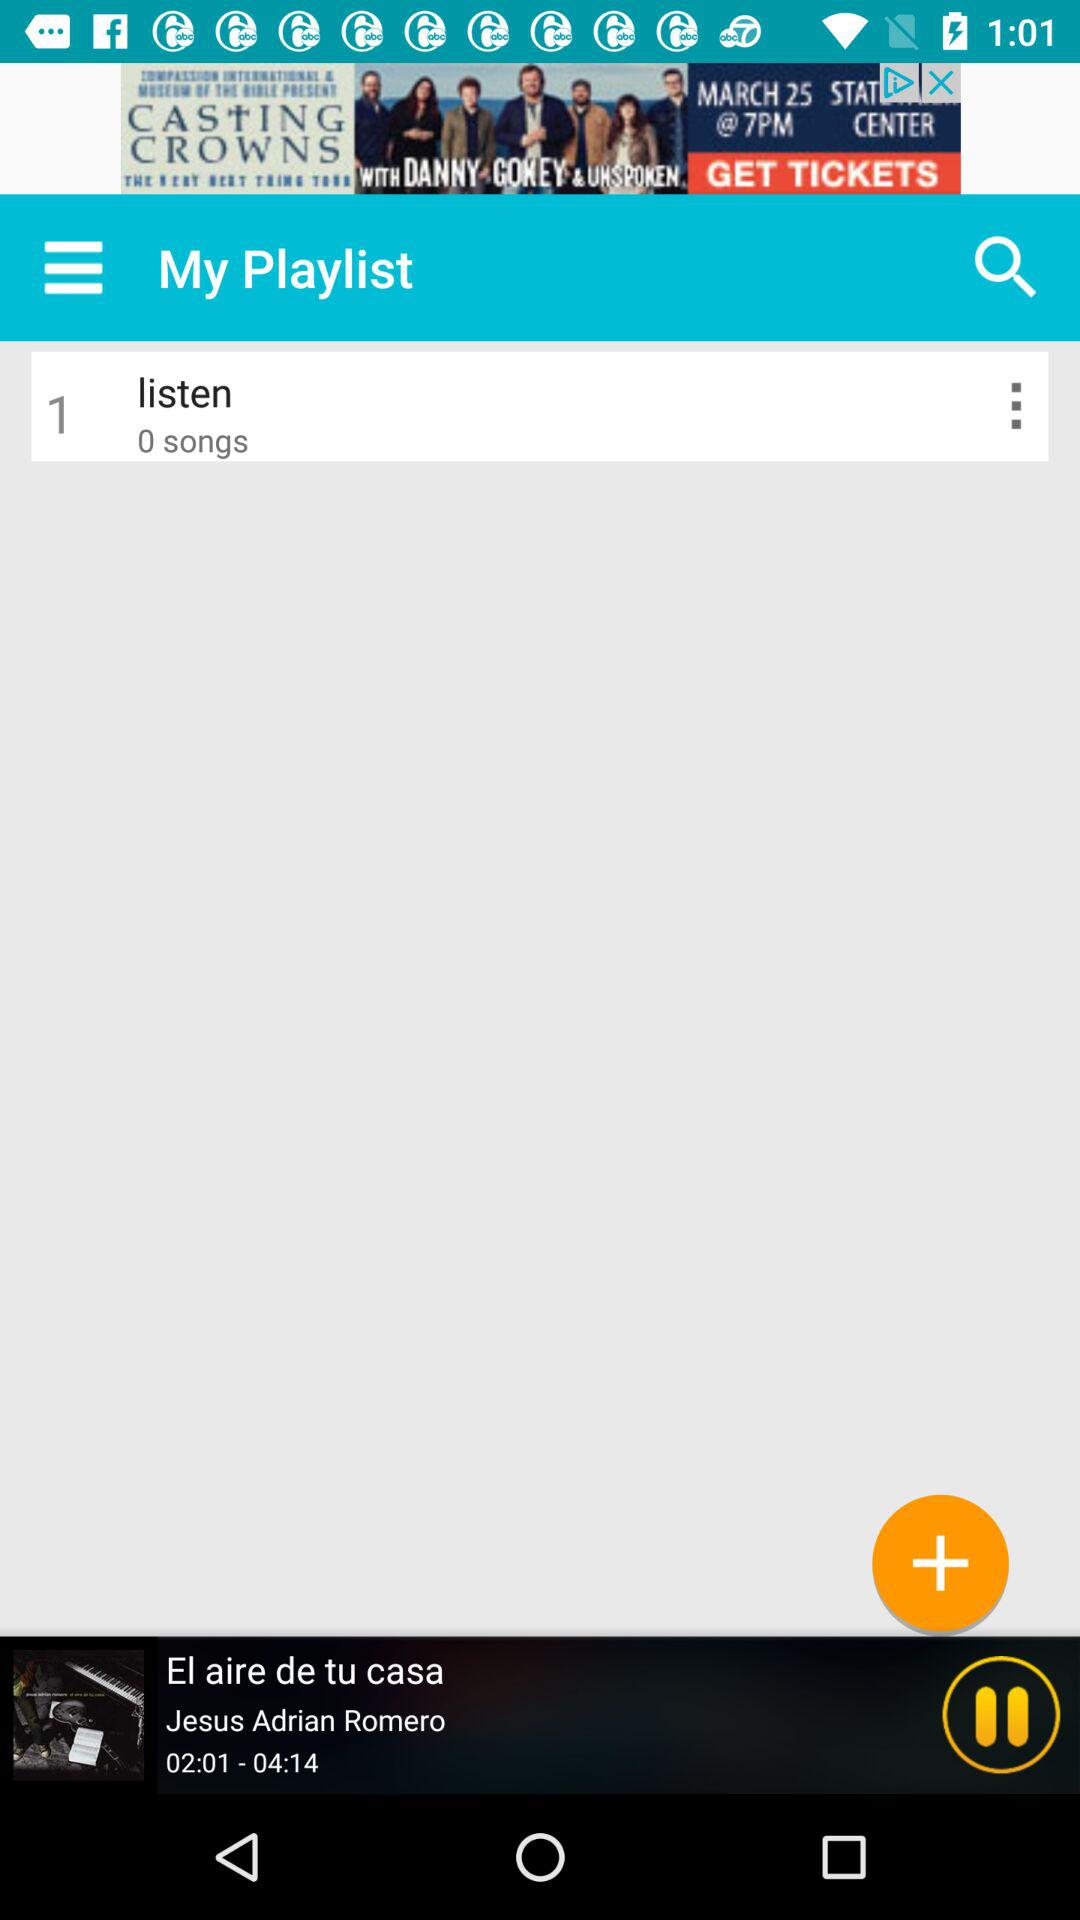Who is the singer of the song? The singer of the song is Jesus Adrian Romero. 